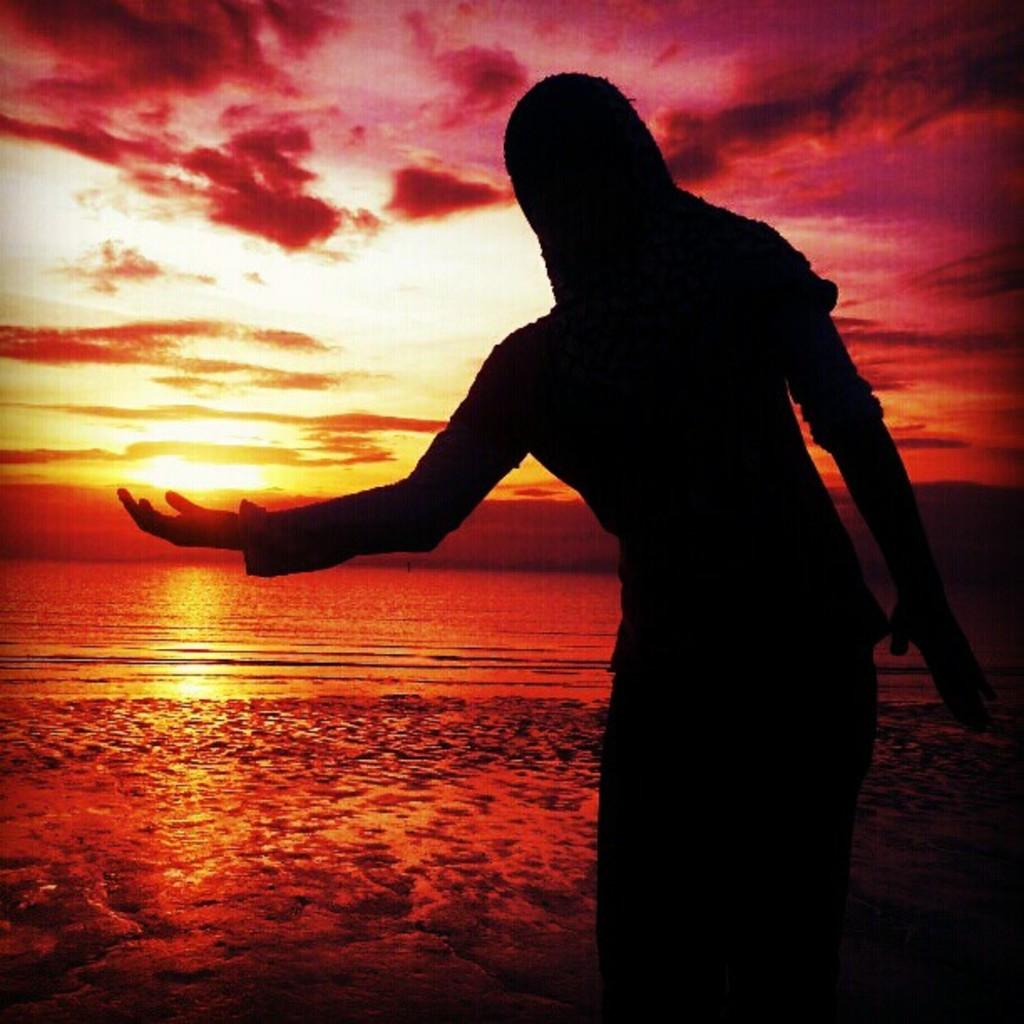What is the main subject of the image? There is a person standing in the center of the image. What can be seen in the background of the image? The sky, clouds, the sun, water, and a few other objects are visible in the background of the image. Can you describe the weather conditions in the image? The presence of clouds and the sun suggests it is partly cloudy. What type of salt is being used by the judge in the image? There is no judge or salt present in the image. 